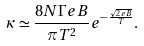Convert formula to latex. <formula><loc_0><loc_0><loc_500><loc_500>\kappa \simeq \frac { 8 N \Gamma e B } { \pi T ^ { 2 } } e ^ { - \frac { \sqrt { 2 e B } } { T } } .</formula> 